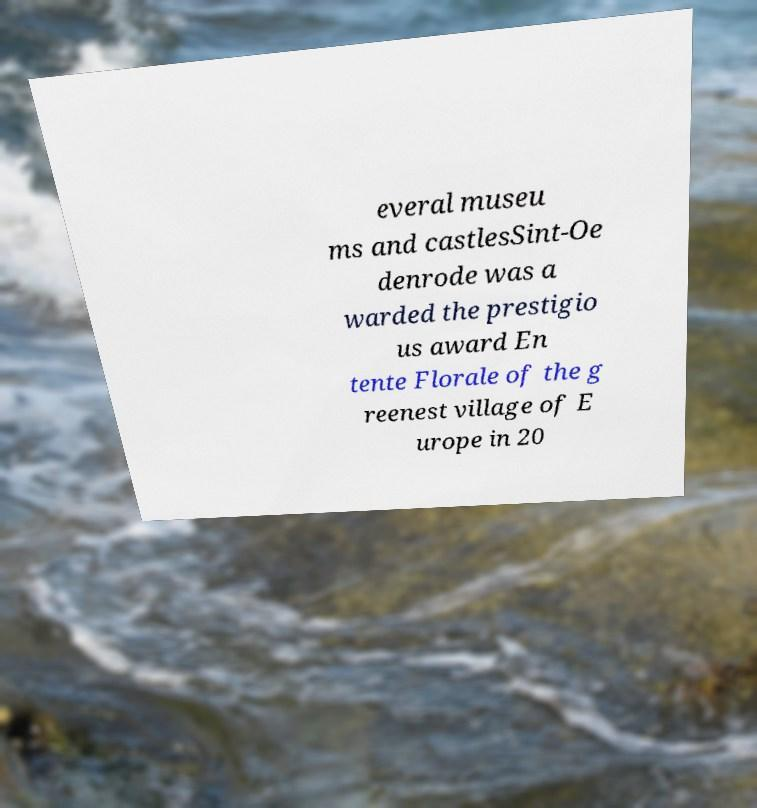There's text embedded in this image that I need extracted. Can you transcribe it verbatim? everal museu ms and castlesSint-Oe denrode was a warded the prestigio us award En tente Florale of the g reenest village of E urope in 20 